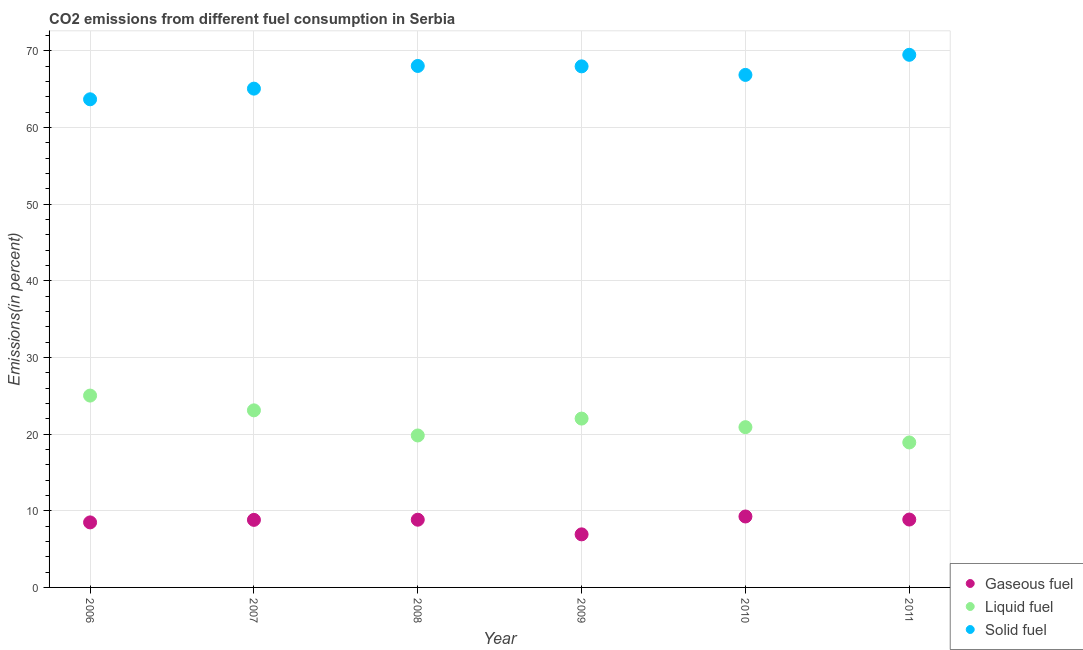How many different coloured dotlines are there?
Offer a very short reply. 3. What is the percentage of liquid fuel emission in 2006?
Keep it short and to the point. 25.03. Across all years, what is the maximum percentage of liquid fuel emission?
Offer a terse response. 25.03. Across all years, what is the minimum percentage of liquid fuel emission?
Provide a succinct answer. 18.91. In which year was the percentage of gaseous fuel emission maximum?
Your answer should be compact. 2010. In which year was the percentage of solid fuel emission minimum?
Your answer should be very brief. 2006. What is the total percentage of liquid fuel emission in the graph?
Keep it short and to the point. 129.81. What is the difference between the percentage of liquid fuel emission in 2008 and that in 2010?
Give a very brief answer. -1.08. What is the difference between the percentage of gaseous fuel emission in 2011 and the percentage of liquid fuel emission in 2007?
Provide a succinct answer. -14.25. What is the average percentage of solid fuel emission per year?
Provide a short and direct response. 66.86. In the year 2006, what is the difference between the percentage of liquid fuel emission and percentage of gaseous fuel emission?
Your answer should be compact. 16.55. In how many years, is the percentage of gaseous fuel emission greater than 32 %?
Offer a terse response. 0. What is the ratio of the percentage of liquid fuel emission in 2006 to that in 2011?
Keep it short and to the point. 1.32. What is the difference between the highest and the second highest percentage of liquid fuel emission?
Ensure brevity in your answer.  1.93. What is the difference between the highest and the lowest percentage of gaseous fuel emission?
Your response must be concise. 2.33. Is it the case that in every year, the sum of the percentage of gaseous fuel emission and percentage of liquid fuel emission is greater than the percentage of solid fuel emission?
Provide a succinct answer. No. Does the percentage of liquid fuel emission monotonically increase over the years?
Offer a terse response. No. Is the percentage of solid fuel emission strictly greater than the percentage of liquid fuel emission over the years?
Your answer should be very brief. Yes. How many years are there in the graph?
Your answer should be compact. 6. What is the difference between two consecutive major ticks on the Y-axis?
Your answer should be very brief. 10. Are the values on the major ticks of Y-axis written in scientific E-notation?
Offer a very short reply. No. Does the graph contain any zero values?
Offer a very short reply. No. Where does the legend appear in the graph?
Provide a succinct answer. Bottom right. What is the title of the graph?
Provide a succinct answer. CO2 emissions from different fuel consumption in Serbia. What is the label or title of the Y-axis?
Provide a short and direct response. Emissions(in percent). What is the Emissions(in percent) in Gaseous fuel in 2006?
Your answer should be very brief. 8.48. What is the Emissions(in percent) of Liquid fuel in 2006?
Provide a succinct answer. 25.03. What is the Emissions(in percent) in Solid fuel in 2006?
Provide a short and direct response. 63.69. What is the Emissions(in percent) in Gaseous fuel in 2007?
Your answer should be compact. 8.81. What is the Emissions(in percent) in Liquid fuel in 2007?
Make the answer very short. 23.1. What is the Emissions(in percent) of Solid fuel in 2007?
Give a very brief answer. 65.08. What is the Emissions(in percent) in Gaseous fuel in 2008?
Your answer should be compact. 8.84. What is the Emissions(in percent) in Liquid fuel in 2008?
Make the answer very short. 19.83. What is the Emissions(in percent) of Solid fuel in 2008?
Give a very brief answer. 68.04. What is the Emissions(in percent) of Gaseous fuel in 2009?
Make the answer very short. 6.92. What is the Emissions(in percent) in Liquid fuel in 2009?
Offer a terse response. 22.03. What is the Emissions(in percent) of Solid fuel in 2009?
Give a very brief answer. 67.99. What is the Emissions(in percent) of Gaseous fuel in 2010?
Provide a succinct answer. 9.26. What is the Emissions(in percent) in Liquid fuel in 2010?
Your response must be concise. 20.91. What is the Emissions(in percent) of Solid fuel in 2010?
Ensure brevity in your answer.  66.87. What is the Emissions(in percent) of Gaseous fuel in 2011?
Make the answer very short. 8.86. What is the Emissions(in percent) in Liquid fuel in 2011?
Offer a very short reply. 18.91. What is the Emissions(in percent) of Solid fuel in 2011?
Provide a short and direct response. 69.49. Across all years, what is the maximum Emissions(in percent) in Gaseous fuel?
Offer a terse response. 9.26. Across all years, what is the maximum Emissions(in percent) in Liquid fuel?
Keep it short and to the point. 25.03. Across all years, what is the maximum Emissions(in percent) of Solid fuel?
Ensure brevity in your answer.  69.49. Across all years, what is the minimum Emissions(in percent) of Gaseous fuel?
Give a very brief answer. 6.92. Across all years, what is the minimum Emissions(in percent) of Liquid fuel?
Provide a short and direct response. 18.91. Across all years, what is the minimum Emissions(in percent) in Solid fuel?
Ensure brevity in your answer.  63.69. What is the total Emissions(in percent) in Gaseous fuel in the graph?
Ensure brevity in your answer.  51.17. What is the total Emissions(in percent) of Liquid fuel in the graph?
Provide a succinct answer. 129.81. What is the total Emissions(in percent) in Solid fuel in the graph?
Keep it short and to the point. 401.15. What is the difference between the Emissions(in percent) of Gaseous fuel in 2006 and that in 2007?
Your answer should be compact. -0.33. What is the difference between the Emissions(in percent) in Liquid fuel in 2006 and that in 2007?
Provide a succinct answer. 1.93. What is the difference between the Emissions(in percent) of Solid fuel in 2006 and that in 2007?
Make the answer very short. -1.39. What is the difference between the Emissions(in percent) in Gaseous fuel in 2006 and that in 2008?
Your answer should be very brief. -0.35. What is the difference between the Emissions(in percent) of Liquid fuel in 2006 and that in 2008?
Your response must be concise. 5.2. What is the difference between the Emissions(in percent) in Solid fuel in 2006 and that in 2008?
Provide a succinct answer. -4.35. What is the difference between the Emissions(in percent) in Gaseous fuel in 2006 and that in 2009?
Offer a terse response. 1.56. What is the difference between the Emissions(in percent) of Liquid fuel in 2006 and that in 2009?
Make the answer very short. 3. What is the difference between the Emissions(in percent) of Solid fuel in 2006 and that in 2009?
Give a very brief answer. -4.3. What is the difference between the Emissions(in percent) in Gaseous fuel in 2006 and that in 2010?
Offer a terse response. -0.77. What is the difference between the Emissions(in percent) of Liquid fuel in 2006 and that in 2010?
Provide a short and direct response. 4.12. What is the difference between the Emissions(in percent) in Solid fuel in 2006 and that in 2010?
Give a very brief answer. -3.18. What is the difference between the Emissions(in percent) of Gaseous fuel in 2006 and that in 2011?
Your answer should be compact. -0.37. What is the difference between the Emissions(in percent) in Liquid fuel in 2006 and that in 2011?
Ensure brevity in your answer.  6.12. What is the difference between the Emissions(in percent) in Solid fuel in 2006 and that in 2011?
Offer a very short reply. -5.8. What is the difference between the Emissions(in percent) in Gaseous fuel in 2007 and that in 2008?
Make the answer very short. -0.02. What is the difference between the Emissions(in percent) in Liquid fuel in 2007 and that in 2008?
Your response must be concise. 3.28. What is the difference between the Emissions(in percent) in Solid fuel in 2007 and that in 2008?
Offer a terse response. -2.96. What is the difference between the Emissions(in percent) in Gaseous fuel in 2007 and that in 2009?
Your response must be concise. 1.89. What is the difference between the Emissions(in percent) of Liquid fuel in 2007 and that in 2009?
Ensure brevity in your answer.  1.07. What is the difference between the Emissions(in percent) in Solid fuel in 2007 and that in 2009?
Keep it short and to the point. -2.91. What is the difference between the Emissions(in percent) in Gaseous fuel in 2007 and that in 2010?
Ensure brevity in your answer.  -0.44. What is the difference between the Emissions(in percent) in Liquid fuel in 2007 and that in 2010?
Keep it short and to the point. 2.19. What is the difference between the Emissions(in percent) in Solid fuel in 2007 and that in 2010?
Your answer should be compact. -1.79. What is the difference between the Emissions(in percent) of Gaseous fuel in 2007 and that in 2011?
Offer a terse response. -0.04. What is the difference between the Emissions(in percent) of Liquid fuel in 2007 and that in 2011?
Your response must be concise. 4.19. What is the difference between the Emissions(in percent) in Solid fuel in 2007 and that in 2011?
Make the answer very short. -4.41. What is the difference between the Emissions(in percent) in Gaseous fuel in 2008 and that in 2009?
Your answer should be very brief. 1.91. What is the difference between the Emissions(in percent) in Liquid fuel in 2008 and that in 2009?
Your response must be concise. -2.2. What is the difference between the Emissions(in percent) in Solid fuel in 2008 and that in 2009?
Your answer should be compact. 0.05. What is the difference between the Emissions(in percent) of Gaseous fuel in 2008 and that in 2010?
Offer a terse response. -0.42. What is the difference between the Emissions(in percent) of Liquid fuel in 2008 and that in 2010?
Your response must be concise. -1.08. What is the difference between the Emissions(in percent) in Solid fuel in 2008 and that in 2010?
Keep it short and to the point. 1.17. What is the difference between the Emissions(in percent) in Gaseous fuel in 2008 and that in 2011?
Your answer should be compact. -0.02. What is the difference between the Emissions(in percent) of Liquid fuel in 2008 and that in 2011?
Give a very brief answer. 0.91. What is the difference between the Emissions(in percent) in Solid fuel in 2008 and that in 2011?
Make the answer very short. -1.45. What is the difference between the Emissions(in percent) in Gaseous fuel in 2009 and that in 2010?
Offer a very short reply. -2.33. What is the difference between the Emissions(in percent) in Liquid fuel in 2009 and that in 2010?
Offer a terse response. 1.12. What is the difference between the Emissions(in percent) of Solid fuel in 2009 and that in 2010?
Give a very brief answer. 1.12. What is the difference between the Emissions(in percent) in Gaseous fuel in 2009 and that in 2011?
Give a very brief answer. -1.93. What is the difference between the Emissions(in percent) in Liquid fuel in 2009 and that in 2011?
Provide a short and direct response. 3.11. What is the difference between the Emissions(in percent) of Solid fuel in 2009 and that in 2011?
Provide a succinct answer. -1.51. What is the difference between the Emissions(in percent) of Gaseous fuel in 2010 and that in 2011?
Offer a very short reply. 0.4. What is the difference between the Emissions(in percent) in Liquid fuel in 2010 and that in 2011?
Your answer should be very brief. 2. What is the difference between the Emissions(in percent) in Solid fuel in 2010 and that in 2011?
Keep it short and to the point. -2.62. What is the difference between the Emissions(in percent) of Gaseous fuel in 2006 and the Emissions(in percent) of Liquid fuel in 2007?
Ensure brevity in your answer.  -14.62. What is the difference between the Emissions(in percent) in Gaseous fuel in 2006 and the Emissions(in percent) in Solid fuel in 2007?
Offer a terse response. -56.59. What is the difference between the Emissions(in percent) in Liquid fuel in 2006 and the Emissions(in percent) in Solid fuel in 2007?
Ensure brevity in your answer.  -40.05. What is the difference between the Emissions(in percent) in Gaseous fuel in 2006 and the Emissions(in percent) in Liquid fuel in 2008?
Your response must be concise. -11.34. What is the difference between the Emissions(in percent) in Gaseous fuel in 2006 and the Emissions(in percent) in Solid fuel in 2008?
Provide a succinct answer. -59.55. What is the difference between the Emissions(in percent) of Liquid fuel in 2006 and the Emissions(in percent) of Solid fuel in 2008?
Offer a very short reply. -43.01. What is the difference between the Emissions(in percent) in Gaseous fuel in 2006 and the Emissions(in percent) in Liquid fuel in 2009?
Offer a terse response. -13.54. What is the difference between the Emissions(in percent) in Gaseous fuel in 2006 and the Emissions(in percent) in Solid fuel in 2009?
Provide a succinct answer. -59.5. What is the difference between the Emissions(in percent) of Liquid fuel in 2006 and the Emissions(in percent) of Solid fuel in 2009?
Make the answer very short. -42.96. What is the difference between the Emissions(in percent) in Gaseous fuel in 2006 and the Emissions(in percent) in Liquid fuel in 2010?
Offer a terse response. -12.43. What is the difference between the Emissions(in percent) of Gaseous fuel in 2006 and the Emissions(in percent) of Solid fuel in 2010?
Offer a terse response. -58.38. What is the difference between the Emissions(in percent) in Liquid fuel in 2006 and the Emissions(in percent) in Solid fuel in 2010?
Keep it short and to the point. -41.84. What is the difference between the Emissions(in percent) of Gaseous fuel in 2006 and the Emissions(in percent) of Liquid fuel in 2011?
Provide a short and direct response. -10.43. What is the difference between the Emissions(in percent) of Gaseous fuel in 2006 and the Emissions(in percent) of Solid fuel in 2011?
Keep it short and to the point. -61.01. What is the difference between the Emissions(in percent) in Liquid fuel in 2006 and the Emissions(in percent) in Solid fuel in 2011?
Keep it short and to the point. -44.46. What is the difference between the Emissions(in percent) in Gaseous fuel in 2007 and the Emissions(in percent) in Liquid fuel in 2008?
Your answer should be very brief. -11.01. What is the difference between the Emissions(in percent) in Gaseous fuel in 2007 and the Emissions(in percent) in Solid fuel in 2008?
Provide a succinct answer. -59.22. What is the difference between the Emissions(in percent) in Liquid fuel in 2007 and the Emissions(in percent) in Solid fuel in 2008?
Provide a succinct answer. -44.93. What is the difference between the Emissions(in percent) of Gaseous fuel in 2007 and the Emissions(in percent) of Liquid fuel in 2009?
Give a very brief answer. -13.21. What is the difference between the Emissions(in percent) in Gaseous fuel in 2007 and the Emissions(in percent) in Solid fuel in 2009?
Keep it short and to the point. -59.17. What is the difference between the Emissions(in percent) of Liquid fuel in 2007 and the Emissions(in percent) of Solid fuel in 2009?
Ensure brevity in your answer.  -44.88. What is the difference between the Emissions(in percent) of Gaseous fuel in 2007 and the Emissions(in percent) of Liquid fuel in 2010?
Provide a succinct answer. -12.09. What is the difference between the Emissions(in percent) in Gaseous fuel in 2007 and the Emissions(in percent) in Solid fuel in 2010?
Your answer should be very brief. -58.05. What is the difference between the Emissions(in percent) in Liquid fuel in 2007 and the Emissions(in percent) in Solid fuel in 2010?
Give a very brief answer. -43.77. What is the difference between the Emissions(in percent) in Gaseous fuel in 2007 and the Emissions(in percent) in Liquid fuel in 2011?
Give a very brief answer. -10.1. What is the difference between the Emissions(in percent) in Gaseous fuel in 2007 and the Emissions(in percent) in Solid fuel in 2011?
Provide a succinct answer. -60.68. What is the difference between the Emissions(in percent) of Liquid fuel in 2007 and the Emissions(in percent) of Solid fuel in 2011?
Offer a very short reply. -46.39. What is the difference between the Emissions(in percent) in Gaseous fuel in 2008 and the Emissions(in percent) in Liquid fuel in 2009?
Your answer should be compact. -13.19. What is the difference between the Emissions(in percent) of Gaseous fuel in 2008 and the Emissions(in percent) of Solid fuel in 2009?
Your answer should be very brief. -59.15. What is the difference between the Emissions(in percent) of Liquid fuel in 2008 and the Emissions(in percent) of Solid fuel in 2009?
Offer a very short reply. -48.16. What is the difference between the Emissions(in percent) of Gaseous fuel in 2008 and the Emissions(in percent) of Liquid fuel in 2010?
Provide a succinct answer. -12.07. What is the difference between the Emissions(in percent) of Gaseous fuel in 2008 and the Emissions(in percent) of Solid fuel in 2010?
Your answer should be very brief. -58.03. What is the difference between the Emissions(in percent) of Liquid fuel in 2008 and the Emissions(in percent) of Solid fuel in 2010?
Give a very brief answer. -47.04. What is the difference between the Emissions(in percent) of Gaseous fuel in 2008 and the Emissions(in percent) of Liquid fuel in 2011?
Ensure brevity in your answer.  -10.08. What is the difference between the Emissions(in percent) in Gaseous fuel in 2008 and the Emissions(in percent) in Solid fuel in 2011?
Make the answer very short. -60.66. What is the difference between the Emissions(in percent) in Liquid fuel in 2008 and the Emissions(in percent) in Solid fuel in 2011?
Provide a succinct answer. -49.67. What is the difference between the Emissions(in percent) of Gaseous fuel in 2009 and the Emissions(in percent) of Liquid fuel in 2010?
Your response must be concise. -13.99. What is the difference between the Emissions(in percent) in Gaseous fuel in 2009 and the Emissions(in percent) in Solid fuel in 2010?
Your answer should be compact. -59.94. What is the difference between the Emissions(in percent) of Liquid fuel in 2009 and the Emissions(in percent) of Solid fuel in 2010?
Keep it short and to the point. -44.84. What is the difference between the Emissions(in percent) of Gaseous fuel in 2009 and the Emissions(in percent) of Liquid fuel in 2011?
Your answer should be compact. -11.99. What is the difference between the Emissions(in percent) in Gaseous fuel in 2009 and the Emissions(in percent) in Solid fuel in 2011?
Ensure brevity in your answer.  -62.57. What is the difference between the Emissions(in percent) in Liquid fuel in 2009 and the Emissions(in percent) in Solid fuel in 2011?
Keep it short and to the point. -47.46. What is the difference between the Emissions(in percent) in Gaseous fuel in 2010 and the Emissions(in percent) in Liquid fuel in 2011?
Provide a succinct answer. -9.66. What is the difference between the Emissions(in percent) in Gaseous fuel in 2010 and the Emissions(in percent) in Solid fuel in 2011?
Give a very brief answer. -60.24. What is the difference between the Emissions(in percent) in Liquid fuel in 2010 and the Emissions(in percent) in Solid fuel in 2011?
Make the answer very short. -48.58. What is the average Emissions(in percent) in Gaseous fuel per year?
Provide a short and direct response. 8.53. What is the average Emissions(in percent) of Liquid fuel per year?
Make the answer very short. 21.64. What is the average Emissions(in percent) of Solid fuel per year?
Give a very brief answer. 66.86. In the year 2006, what is the difference between the Emissions(in percent) in Gaseous fuel and Emissions(in percent) in Liquid fuel?
Your answer should be very brief. -16.55. In the year 2006, what is the difference between the Emissions(in percent) in Gaseous fuel and Emissions(in percent) in Solid fuel?
Ensure brevity in your answer.  -55.2. In the year 2006, what is the difference between the Emissions(in percent) in Liquid fuel and Emissions(in percent) in Solid fuel?
Your answer should be very brief. -38.66. In the year 2007, what is the difference between the Emissions(in percent) in Gaseous fuel and Emissions(in percent) in Liquid fuel?
Make the answer very short. -14.29. In the year 2007, what is the difference between the Emissions(in percent) of Gaseous fuel and Emissions(in percent) of Solid fuel?
Provide a short and direct response. -56.26. In the year 2007, what is the difference between the Emissions(in percent) in Liquid fuel and Emissions(in percent) in Solid fuel?
Keep it short and to the point. -41.97. In the year 2008, what is the difference between the Emissions(in percent) of Gaseous fuel and Emissions(in percent) of Liquid fuel?
Keep it short and to the point. -10.99. In the year 2008, what is the difference between the Emissions(in percent) of Gaseous fuel and Emissions(in percent) of Solid fuel?
Keep it short and to the point. -59.2. In the year 2008, what is the difference between the Emissions(in percent) in Liquid fuel and Emissions(in percent) in Solid fuel?
Give a very brief answer. -48.21. In the year 2009, what is the difference between the Emissions(in percent) of Gaseous fuel and Emissions(in percent) of Liquid fuel?
Your answer should be compact. -15.1. In the year 2009, what is the difference between the Emissions(in percent) in Gaseous fuel and Emissions(in percent) in Solid fuel?
Offer a very short reply. -61.06. In the year 2009, what is the difference between the Emissions(in percent) in Liquid fuel and Emissions(in percent) in Solid fuel?
Your answer should be very brief. -45.96. In the year 2010, what is the difference between the Emissions(in percent) of Gaseous fuel and Emissions(in percent) of Liquid fuel?
Give a very brief answer. -11.65. In the year 2010, what is the difference between the Emissions(in percent) of Gaseous fuel and Emissions(in percent) of Solid fuel?
Your answer should be compact. -57.61. In the year 2010, what is the difference between the Emissions(in percent) of Liquid fuel and Emissions(in percent) of Solid fuel?
Ensure brevity in your answer.  -45.96. In the year 2011, what is the difference between the Emissions(in percent) in Gaseous fuel and Emissions(in percent) in Liquid fuel?
Ensure brevity in your answer.  -10.06. In the year 2011, what is the difference between the Emissions(in percent) in Gaseous fuel and Emissions(in percent) in Solid fuel?
Give a very brief answer. -60.64. In the year 2011, what is the difference between the Emissions(in percent) in Liquid fuel and Emissions(in percent) in Solid fuel?
Provide a succinct answer. -50.58. What is the ratio of the Emissions(in percent) in Gaseous fuel in 2006 to that in 2007?
Offer a very short reply. 0.96. What is the ratio of the Emissions(in percent) in Liquid fuel in 2006 to that in 2007?
Your response must be concise. 1.08. What is the ratio of the Emissions(in percent) of Solid fuel in 2006 to that in 2007?
Ensure brevity in your answer.  0.98. What is the ratio of the Emissions(in percent) of Gaseous fuel in 2006 to that in 2008?
Make the answer very short. 0.96. What is the ratio of the Emissions(in percent) of Liquid fuel in 2006 to that in 2008?
Give a very brief answer. 1.26. What is the ratio of the Emissions(in percent) in Solid fuel in 2006 to that in 2008?
Provide a succinct answer. 0.94. What is the ratio of the Emissions(in percent) of Gaseous fuel in 2006 to that in 2009?
Offer a terse response. 1.23. What is the ratio of the Emissions(in percent) of Liquid fuel in 2006 to that in 2009?
Make the answer very short. 1.14. What is the ratio of the Emissions(in percent) in Solid fuel in 2006 to that in 2009?
Provide a succinct answer. 0.94. What is the ratio of the Emissions(in percent) in Liquid fuel in 2006 to that in 2010?
Ensure brevity in your answer.  1.2. What is the ratio of the Emissions(in percent) of Gaseous fuel in 2006 to that in 2011?
Ensure brevity in your answer.  0.96. What is the ratio of the Emissions(in percent) of Liquid fuel in 2006 to that in 2011?
Provide a succinct answer. 1.32. What is the ratio of the Emissions(in percent) in Solid fuel in 2006 to that in 2011?
Provide a succinct answer. 0.92. What is the ratio of the Emissions(in percent) in Gaseous fuel in 2007 to that in 2008?
Keep it short and to the point. 1. What is the ratio of the Emissions(in percent) in Liquid fuel in 2007 to that in 2008?
Give a very brief answer. 1.17. What is the ratio of the Emissions(in percent) of Solid fuel in 2007 to that in 2008?
Keep it short and to the point. 0.96. What is the ratio of the Emissions(in percent) in Gaseous fuel in 2007 to that in 2009?
Ensure brevity in your answer.  1.27. What is the ratio of the Emissions(in percent) in Liquid fuel in 2007 to that in 2009?
Offer a terse response. 1.05. What is the ratio of the Emissions(in percent) in Solid fuel in 2007 to that in 2009?
Offer a terse response. 0.96. What is the ratio of the Emissions(in percent) in Gaseous fuel in 2007 to that in 2010?
Offer a very short reply. 0.95. What is the ratio of the Emissions(in percent) of Liquid fuel in 2007 to that in 2010?
Your response must be concise. 1.1. What is the ratio of the Emissions(in percent) in Solid fuel in 2007 to that in 2010?
Make the answer very short. 0.97. What is the ratio of the Emissions(in percent) in Gaseous fuel in 2007 to that in 2011?
Your answer should be compact. 1. What is the ratio of the Emissions(in percent) of Liquid fuel in 2007 to that in 2011?
Offer a terse response. 1.22. What is the ratio of the Emissions(in percent) of Solid fuel in 2007 to that in 2011?
Provide a short and direct response. 0.94. What is the ratio of the Emissions(in percent) in Gaseous fuel in 2008 to that in 2009?
Offer a very short reply. 1.28. What is the ratio of the Emissions(in percent) in Liquid fuel in 2008 to that in 2009?
Offer a terse response. 0.9. What is the ratio of the Emissions(in percent) in Gaseous fuel in 2008 to that in 2010?
Keep it short and to the point. 0.95. What is the ratio of the Emissions(in percent) of Liquid fuel in 2008 to that in 2010?
Your answer should be compact. 0.95. What is the ratio of the Emissions(in percent) in Solid fuel in 2008 to that in 2010?
Ensure brevity in your answer.  1.02. What is the ratio of the Emissions(in percent) in Liquid fuel in 2008 to that in 2011?
Provide a short and direct response. 1.05. What is the ratio of the Emissions(in percent) in Solid fuel in 2008 to that in 2011?
Provide a short and direct response. 0.98. What is the ratio of the Emissions(in percent) of Gaseous fuel in 2009 to that in 2010?
Your answer should be compact. 0.75. What is the ratio of the Emissions(in percent) of Liquid fuel in 2009 to that in 2010?
Offer a very short reply. 1.05. What is the ratio of the Emissions(in percent) of Solid fuel in 2009 to that in 2010?
Your answer should be very brief. 1.02. What is the ratio of the Emissions(in percent) in Gaseous fuel in 2009 to that in 2011?
Provide a succinct answer. 0.78. What is the ratio of the Emissions(in percent) of Liquid fuel in 2009 to that in 2011?
Provide a succinct answer. 1.16. What is the ratio of the Emissions(in percent) in Solid fuel in 2009 to that in 2011?
Offer a very short reply. 0.98. What is the ratio of the Emissions(in percent) in Gaseous fuel in 2010 to that in 2011?
Your answer should be compact. 1.04. What is the ratio of the Emissions(in percent) of Liquid fuel in 2010 to that in 2011?
Your answer should be compact. 1.11. What is the ratio of the Emissions(in percent) in Solid fuel in 2010 to that in 2011?
Your answer should be very brief. 0.96. What is the difference between the highest and the second highest Emissions(in percent) of Gaseous fuel?
Your answer should be compact. 0.4. What is the difference between the highest and the second highest Emissions(in percent) in Liquid fuel?
Keep it short and to the point. 1.93. What is the difference between the highest and the second highest Emissions(in percent) of Solid fuel?
Provide a short and direct response. 1.45. What is the difference between the highest and the lowest Emissions(in percent) of Gaseous fuel?
Give a very brief answer. 2.33. What is the difference between the highest and the lowest Emissions(in percent) in Liquid fuel?
Give a very brief answer. 6.12. What is the difference between the highest and the lowest Emissions(in percent) in Solid fuel?
Give a very brief answer. 5.8. 